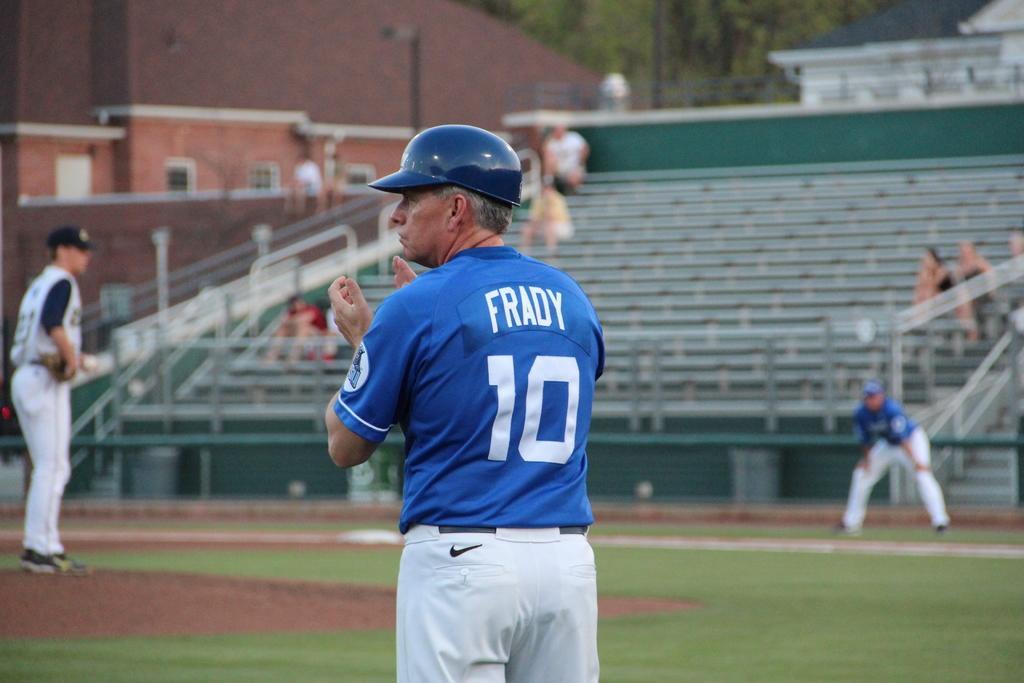In one or two sentences, can you explain what this image depicts? In this picture we can see three men standing on the ground and in the background we can see some people sitting on steps, buildings, trees. 